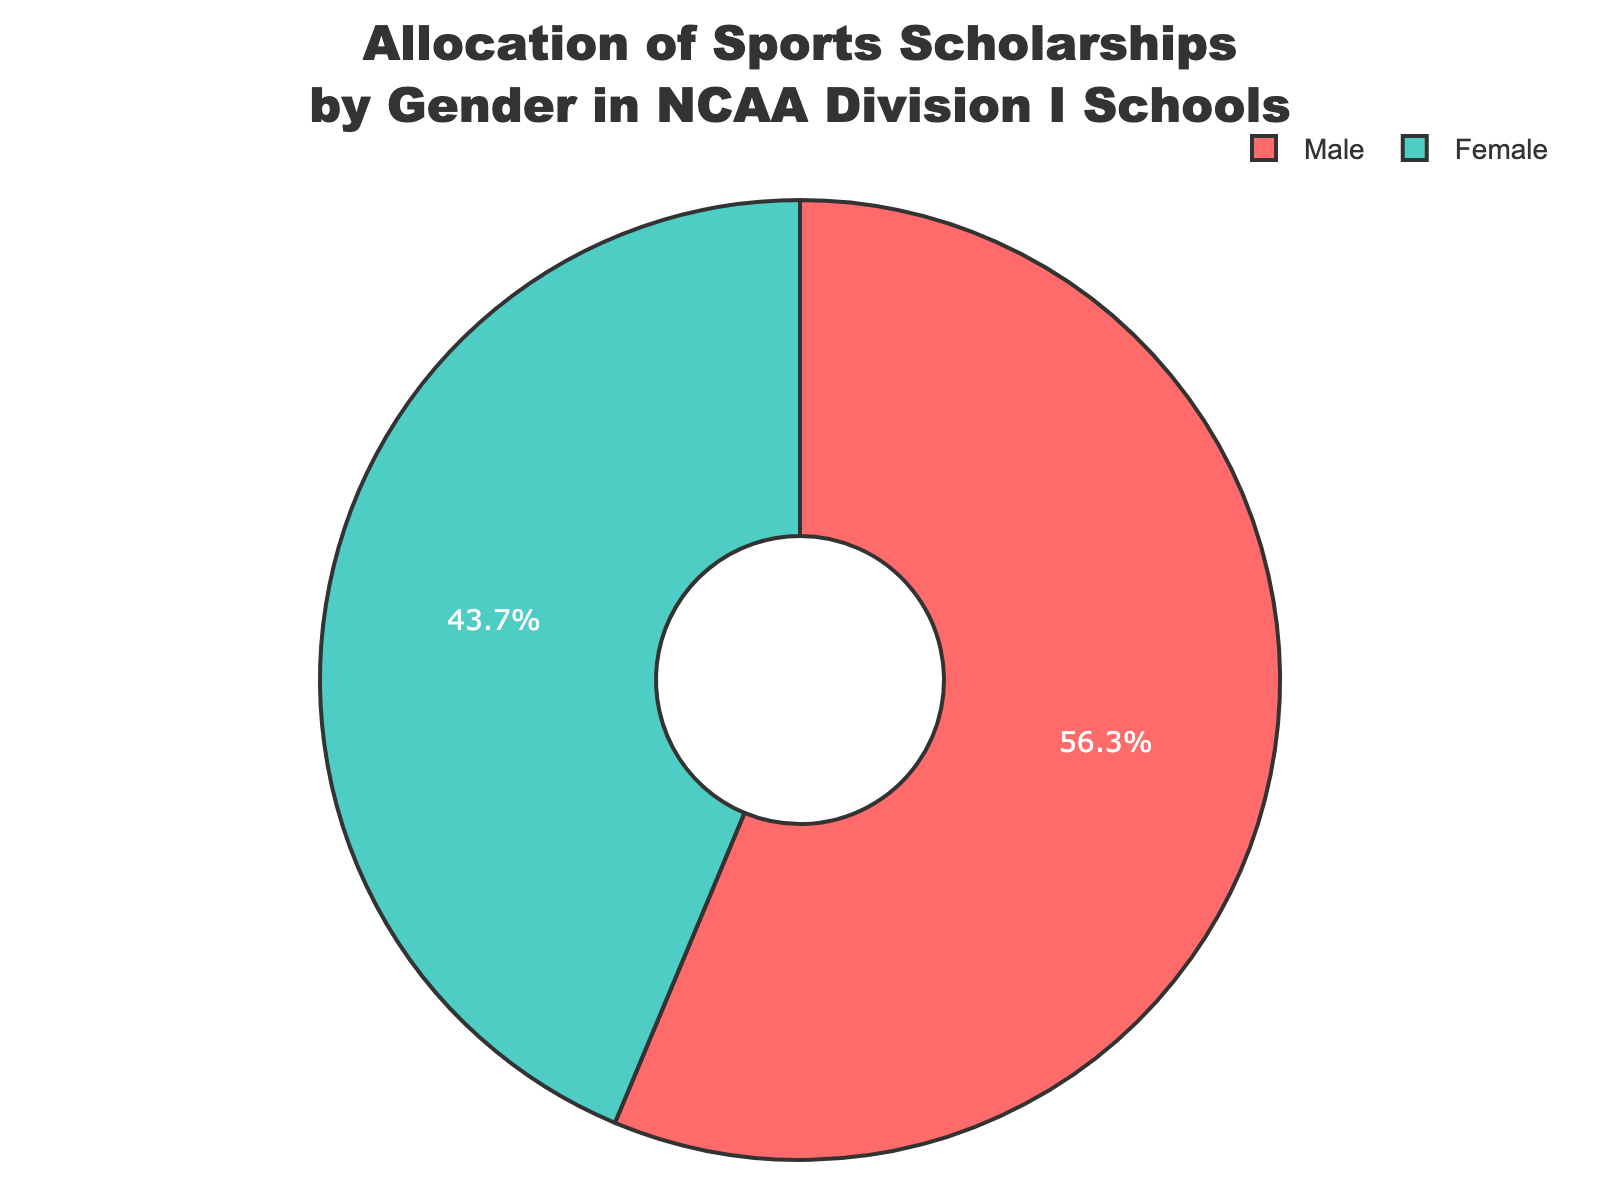What's the percentage of sports scholarships given to female athletes in NCAA Division I schools? According to the pie chart, the percentage of sports scholarships allocated to female athletes is given directly.
Answer: 43.7% What's the difference in sports scholarship allocation between male and female athletes in NCAA Division I schools? To find the difference, subtract the percentage of female scholarships from the percentage of male scholarships: 56.3% - 43.7% = 12.6%.
Answer: 12.6% Which gender receives more sports scholarships in NCAA Division I schools? The pie chart shows that male athletes receive 56.3% of the scholarships, which is more than the 43.7% received by female athletes.
Answer: Male If the total number of sports scholarships is 10,000, how many scholarships are given to female athletes? Calculate the number of female scholarships by multiplying the total number by the percentage for females: 10,000 * 43.7% = 4,370.
Answer: 4,370 What percentage of sports scholarships do male and female athletes collectively receive? Add the individual percentages to get the total allocation: 56.3% + 43.7% = 100%.
Answer: 100% Is the pie chart evenly distributed between male and female sports scholarship allocations? Visually assessing the pie chart, the portions are not equal; the male section is larger, indicating an uneven distribution.
Answer: No Which color represents female athletes in the pie chart? The chart uses a specific color scheme. By visual inspection, the female athletes' portion is represented in light green.
Answer: Light green What percentage difference would result in an equal allocation between male and female athletes? To find this, you need to determine how much of the male allocation should shift to females to equalize: (56.3% - 43.7%) / 2 = 6.3%. Each gender would then have 50%.
Answer: 6.3% If the allocation for female athletes increased by 5%, what would the new percentage distribution be? Increase the female percentage by 5% and decrease the male percentage by 5%: Female: 43.7% + 5% = 48.7%, Male: 56.3% - 5% = 51.3%.
Answer: Female: 48.7%, Male: 51.3% 